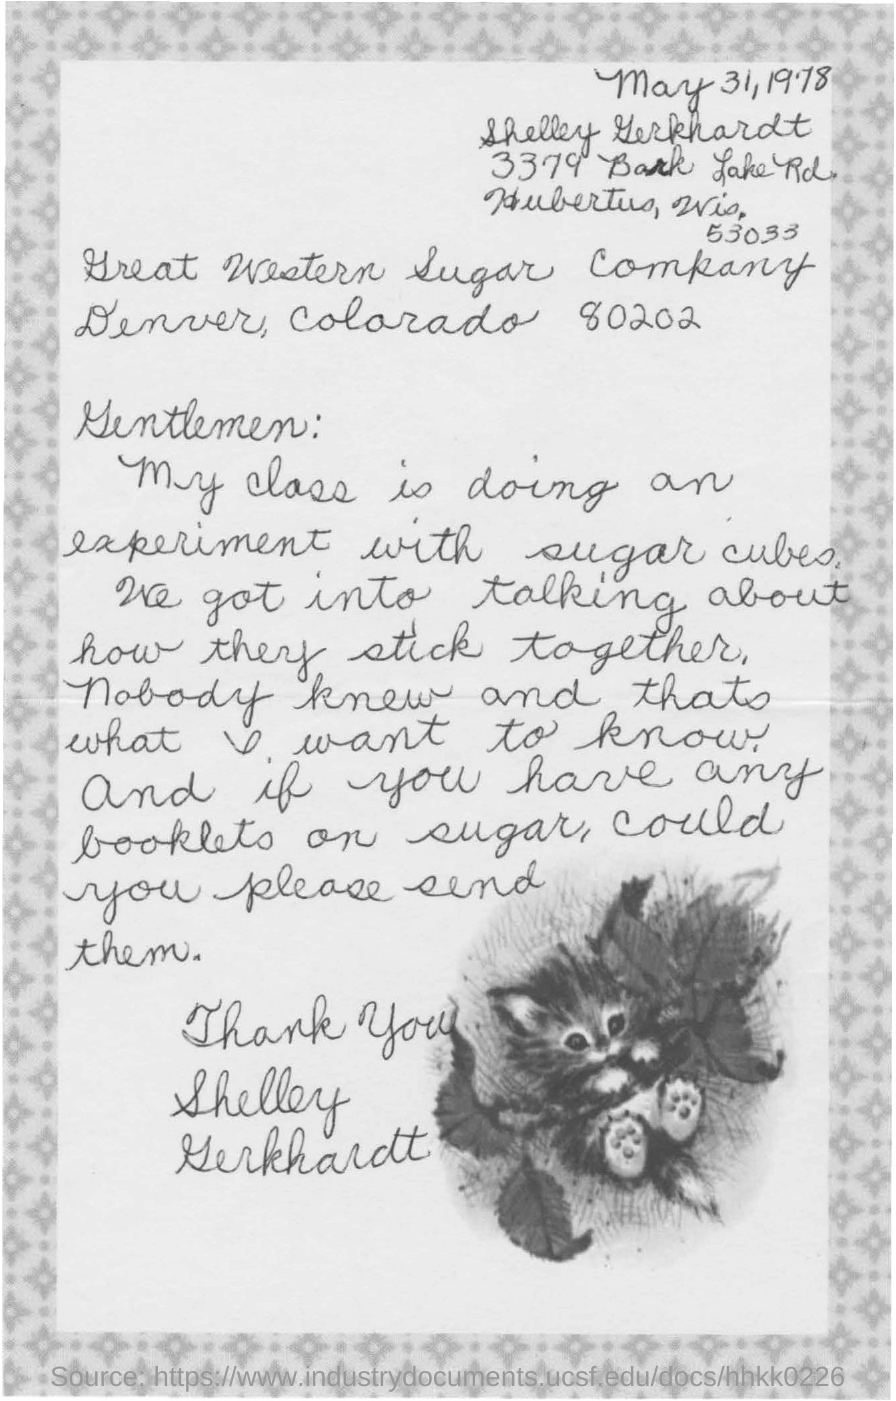What is the date mentioned?
Your answer should be compact. May 31, 1978. By whom is this letter written?
Provide a short and direct response. Shelley Gerkhardt. What is the class experimenting on?
Offer a very short reply. Sugar cubes. 